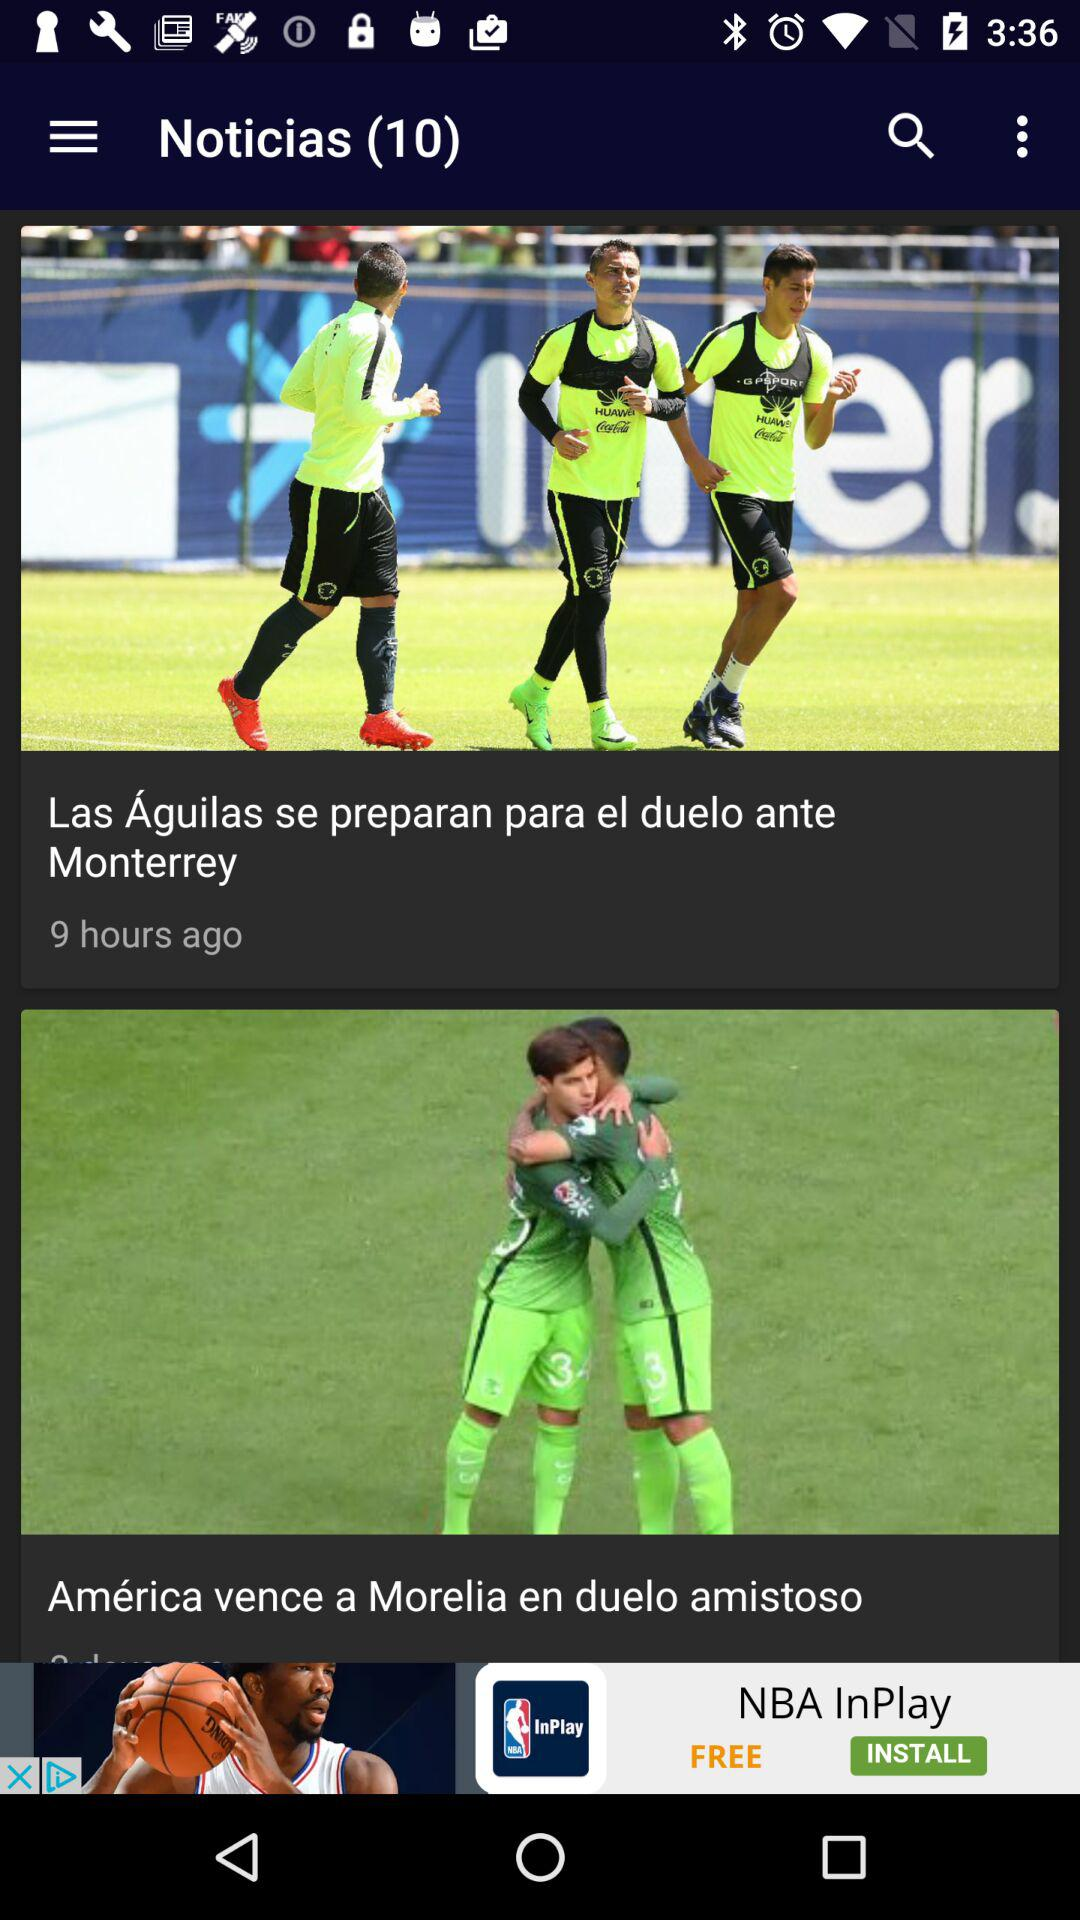How many hours ago was the first item published?
Answer the question using a single word or phrase. 9 